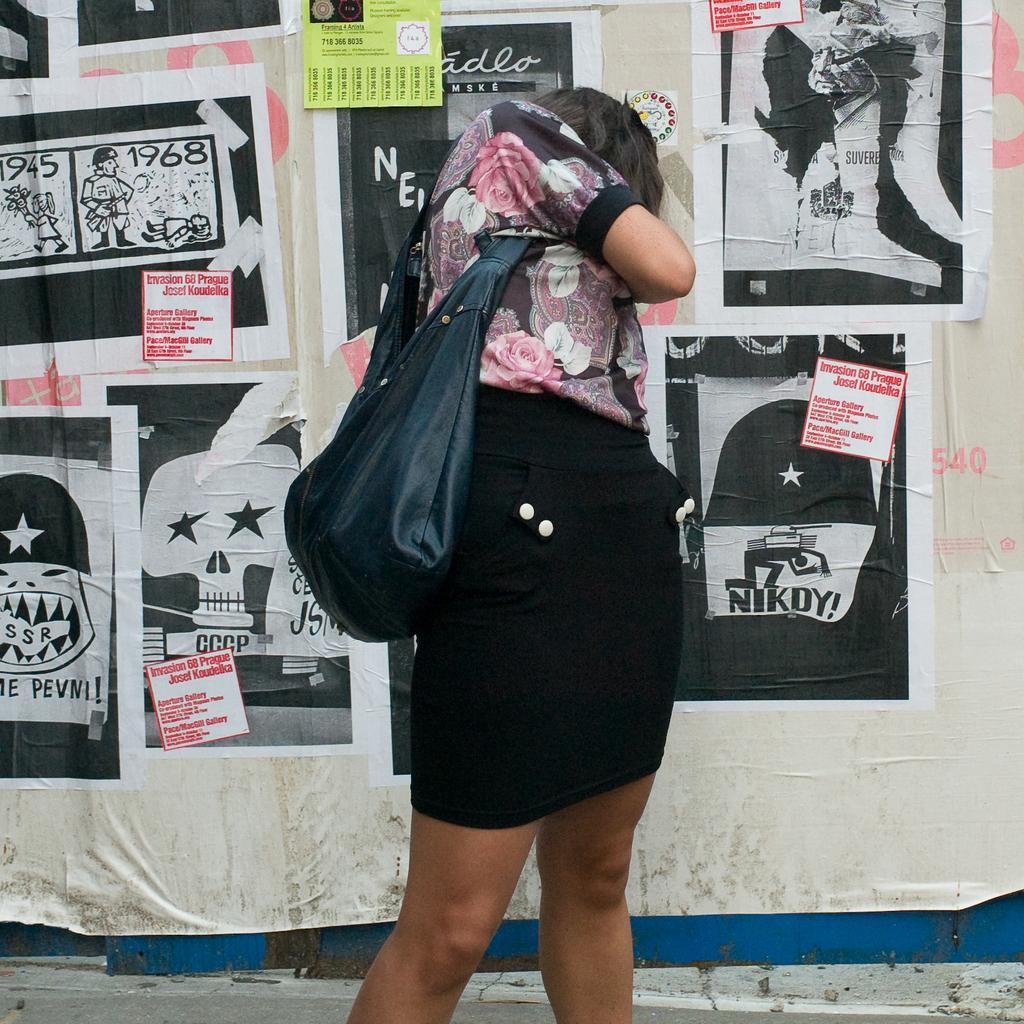Could you give a brief overview of what you see in this image? This woman is standing. This woman wore a bag. On wall there are different type of posters. 